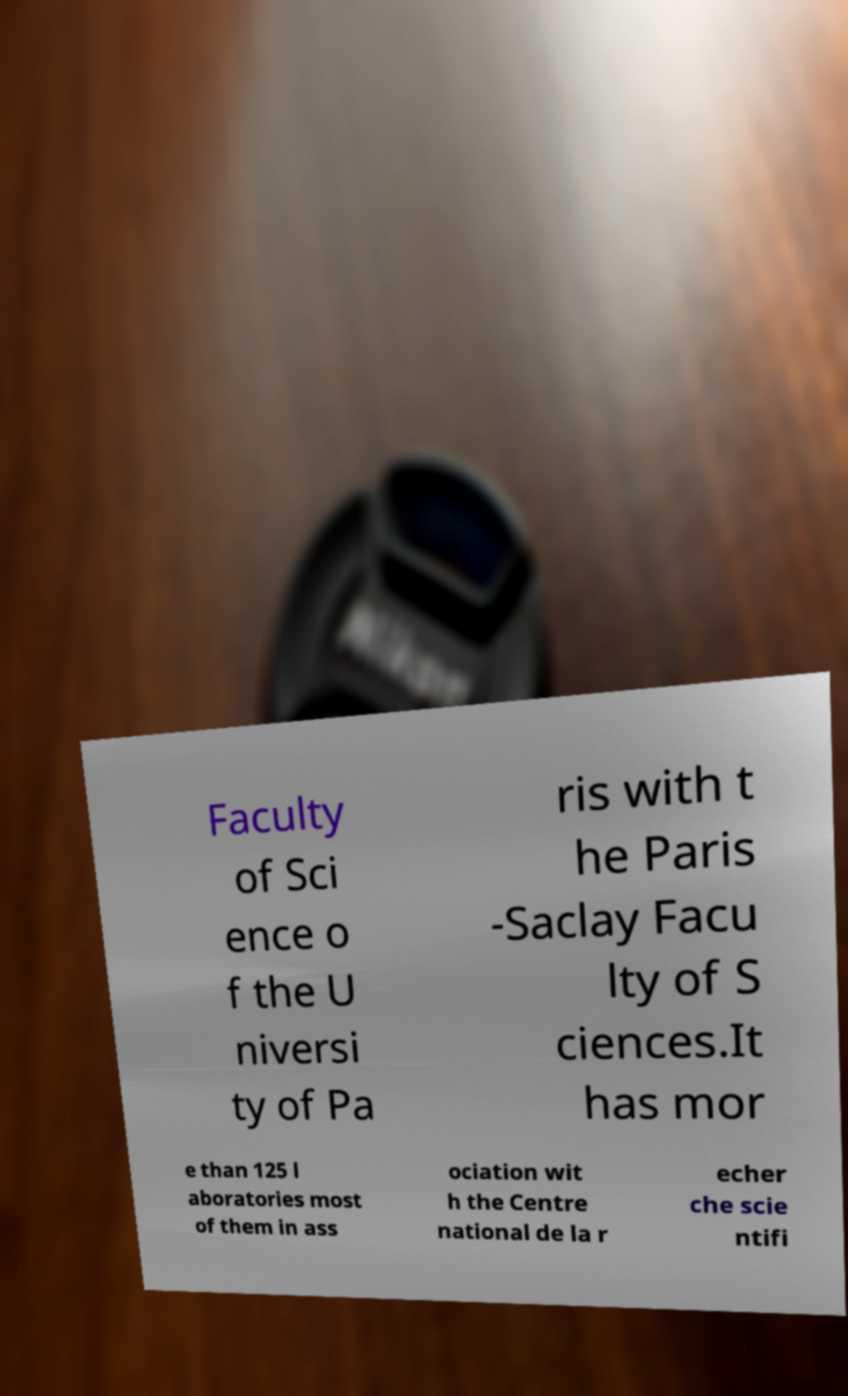What messages or text are displayed in this image? I need them in a readable, typed format. Faculty of Sci ence o f the U niversi ty of Pa ris with t he Paris -Saclay Facu lty of S ciences.It has mor e than 125 l aboratories most of them in ass ociation wit h the Centre national de la r echer che scie ntifi 